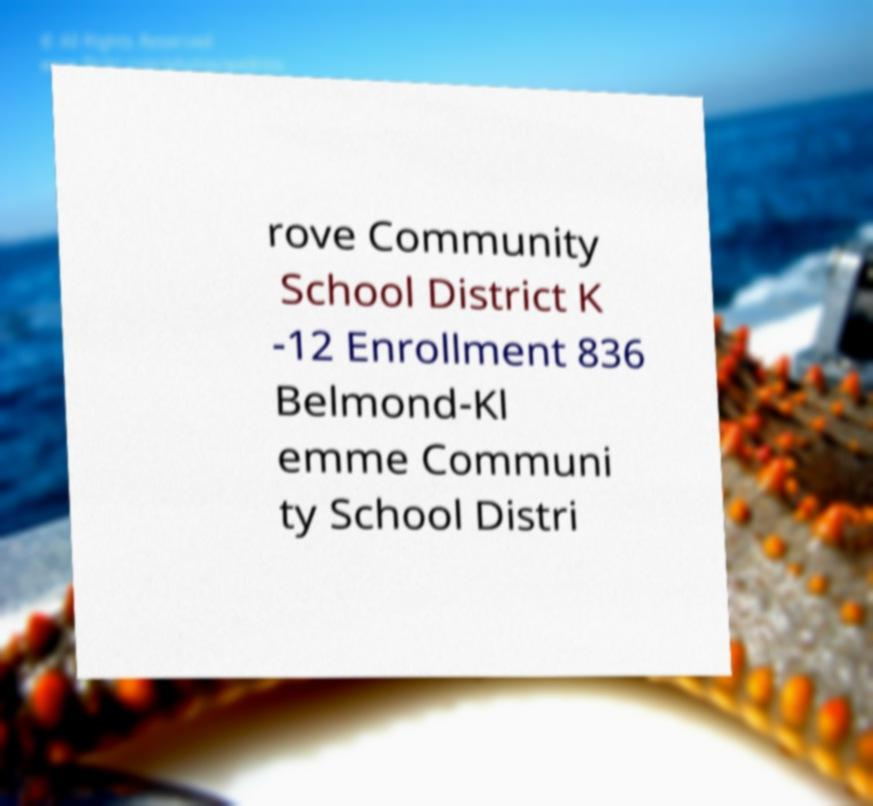Can you accurately transcribe the text from the provided image for me? rove Community School District K -12 Enrollment 836 Belmond-Kl emme Communi ty School Distri 